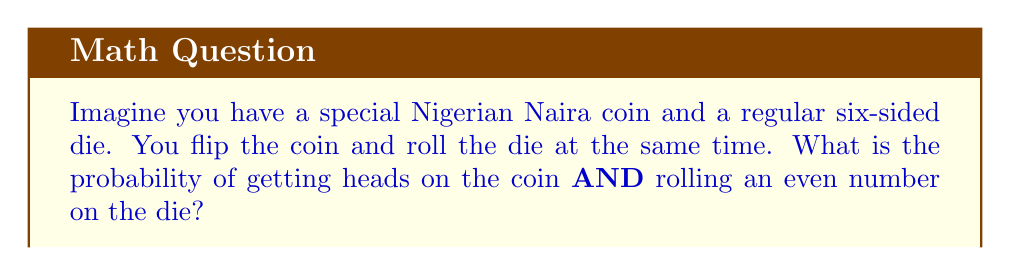Help me with this question. Let's break this down step-by-step:

1. First, we need to understand what outcomes we're looking for:
   - Heads on the coin
   - An even number on the die (2, 4, or 6)

2. For the coin flip:
   - There are two possible outcomes: heads or tails
   - The probability of getting heads is $\frac{1}{2}$

3. For the die roll:
   - There are six possible outcomes: 1, 2, 3, 4, 5, 6
   - Even numbers are 2, 4, and 6
   - The probability of rolling an even number is $\frac{3}{6} = \frac{1}{2}$

4. Now, we need to find the probability of both events happening together:
   - When we have two independent events (the coin flip doesn't affect the die roll and vice versa), we multiply their individual probabilities

5. So, the probability of getting heads AND an even number is:
   $$P(\text{Heads and Even}) = P(\text{Heads}) \times P(\text{Even})$$
   $$P(\text{Heads and Even}) = \frac{1}{2} \times \frac{1}{2} = \frac{1}{4}$$

Therefore, the probability of getting heads on the coin AND rolling an even number on the die is $\frac{1}{4}$ or 0.25 or 25%.
Answer: $\frac{1}{4}$ or 0.25 or 25% 